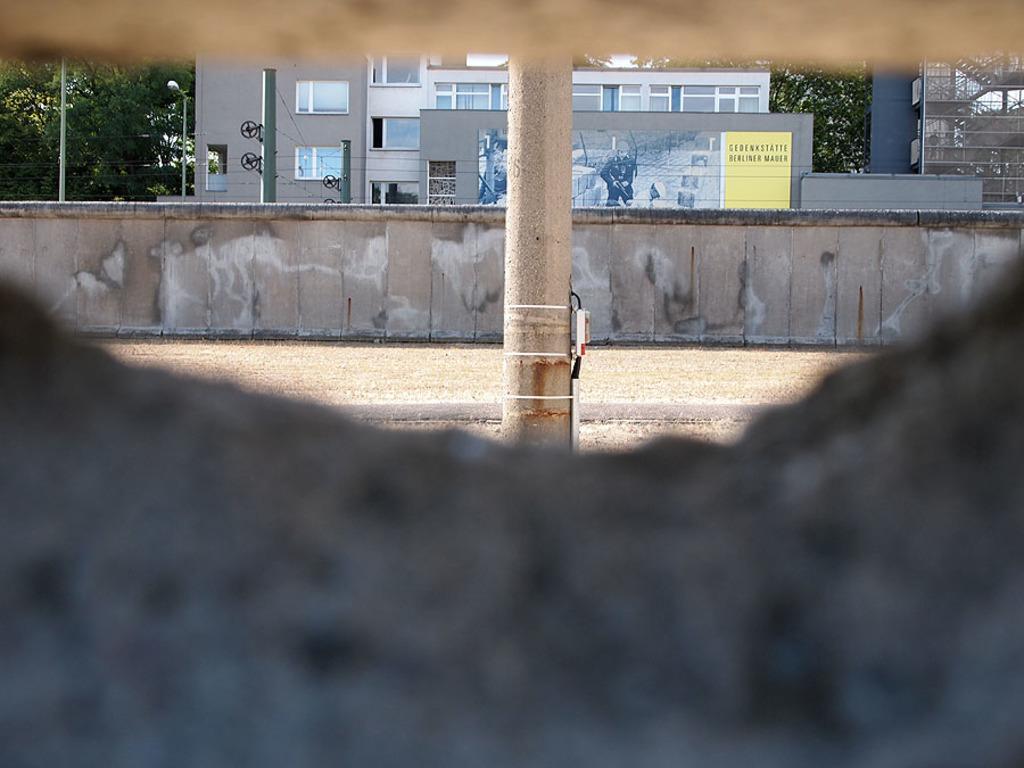Could you give a brief overview of what you see in this image? In this image we can see a hole. Through the hole we can see a pillar, wall. In the back there is a building with windows. On the building there is a banner. In the background there are trees. Also there is a light pole. 